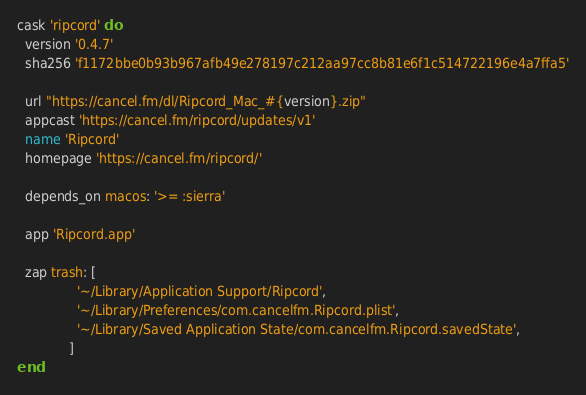<code> <loc_0><loc_0><loc_500><loc_500><_Ruby_>cask 'ripcord' do
  version '0.4.7'
  sha256 'f1172bbe0b93b967afb49e278197c212aa97cc8b81e6f1c514722196e4a7ffa5'

  url "https://cancel.fm/dl/Ripcord_Mac_#{version}.zip"
  appcast 'https://cancel.fm/ripcord/updates/v1'
  name 'Ripcord'
  homepage 'https://cancel.fm/ripcord/'

  depends_on macos: '>= :sierra'

  app 'Ripcord.app'

  zap trash: [
               '~/Library/Application Support/Ripcord',
               '~/Library/Preferences/com.cancelfm.Ripcord.plist',
               '~/Library/Saved Application State/com.cancelfm.Ripcord.savedState',
             ]
end
</code> 